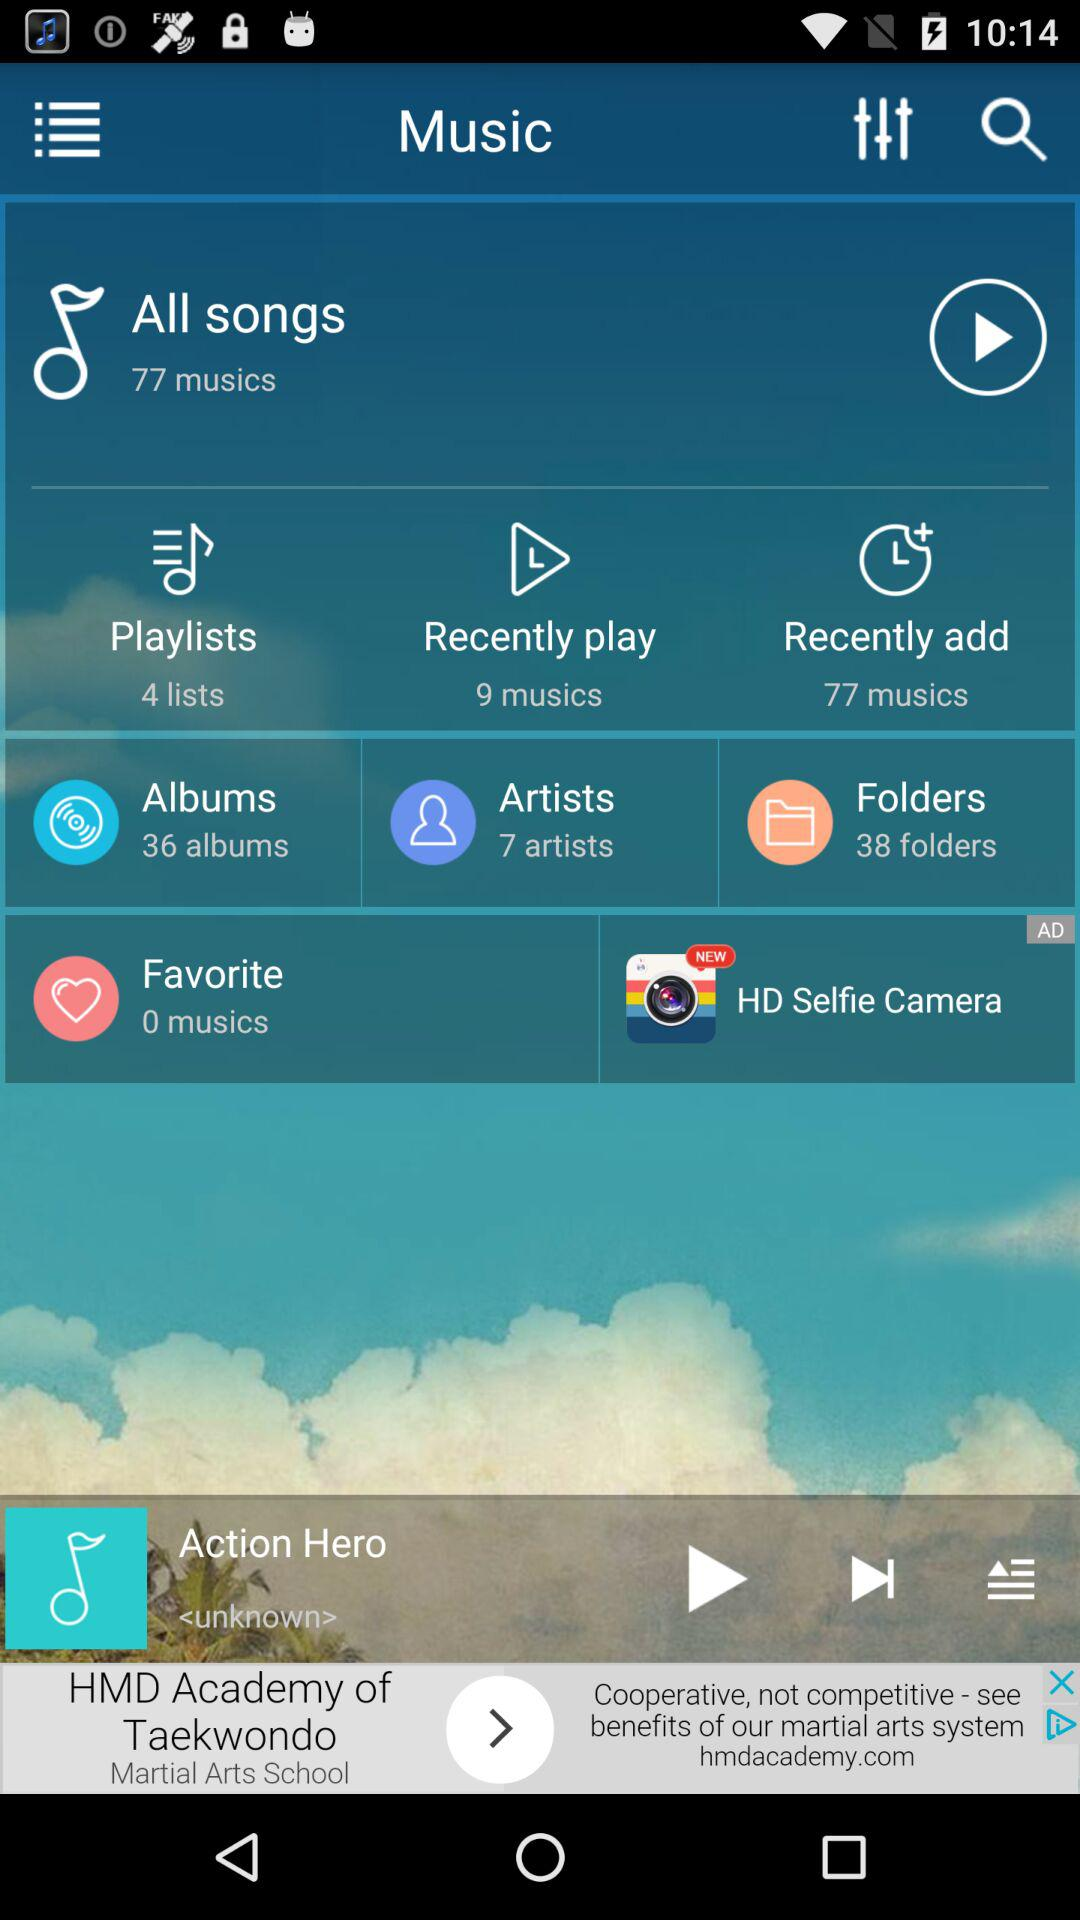What is the total count of the playlists? The total count of the playlists is 4. 